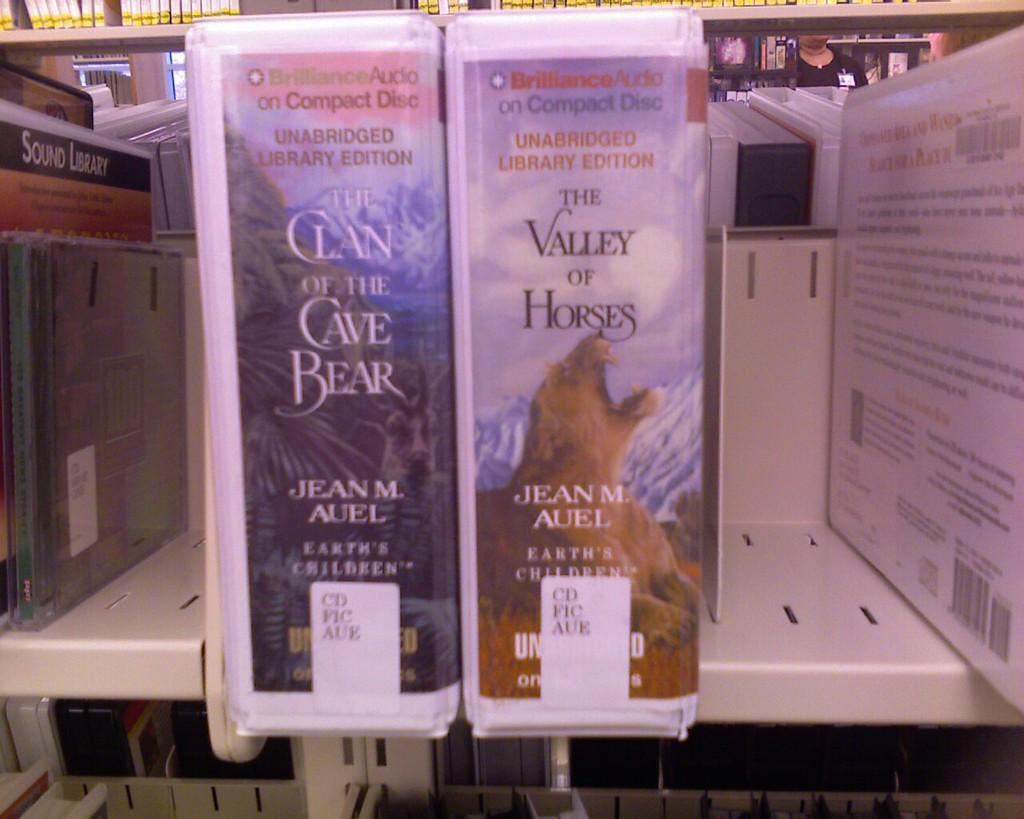<image>
Describe the image concisely. An audiobook of The Valley of Horses sits on a library shelf. 